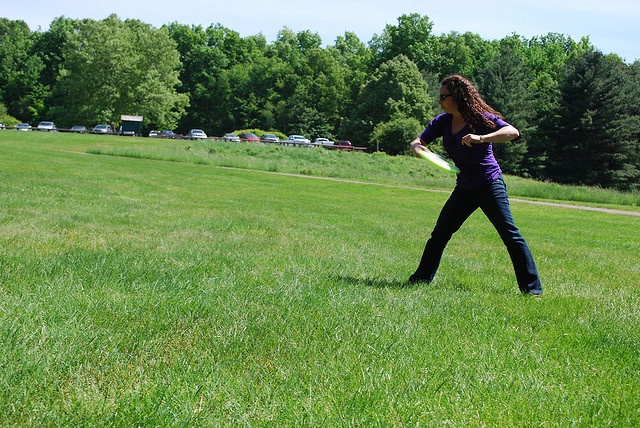Describe the objects in this image and their specific colors. I can see people in lavender, black, maroon, navy, and gray tones, car in lavender, black, lightgreen, olive, and gray tones, frisbee in lavender, ivory, green, lightgreen, and olive tones, car in lavender, black, gray, darkgreen, and white tones, and car in lavender, white, lightblue, and gray tones in this image. 